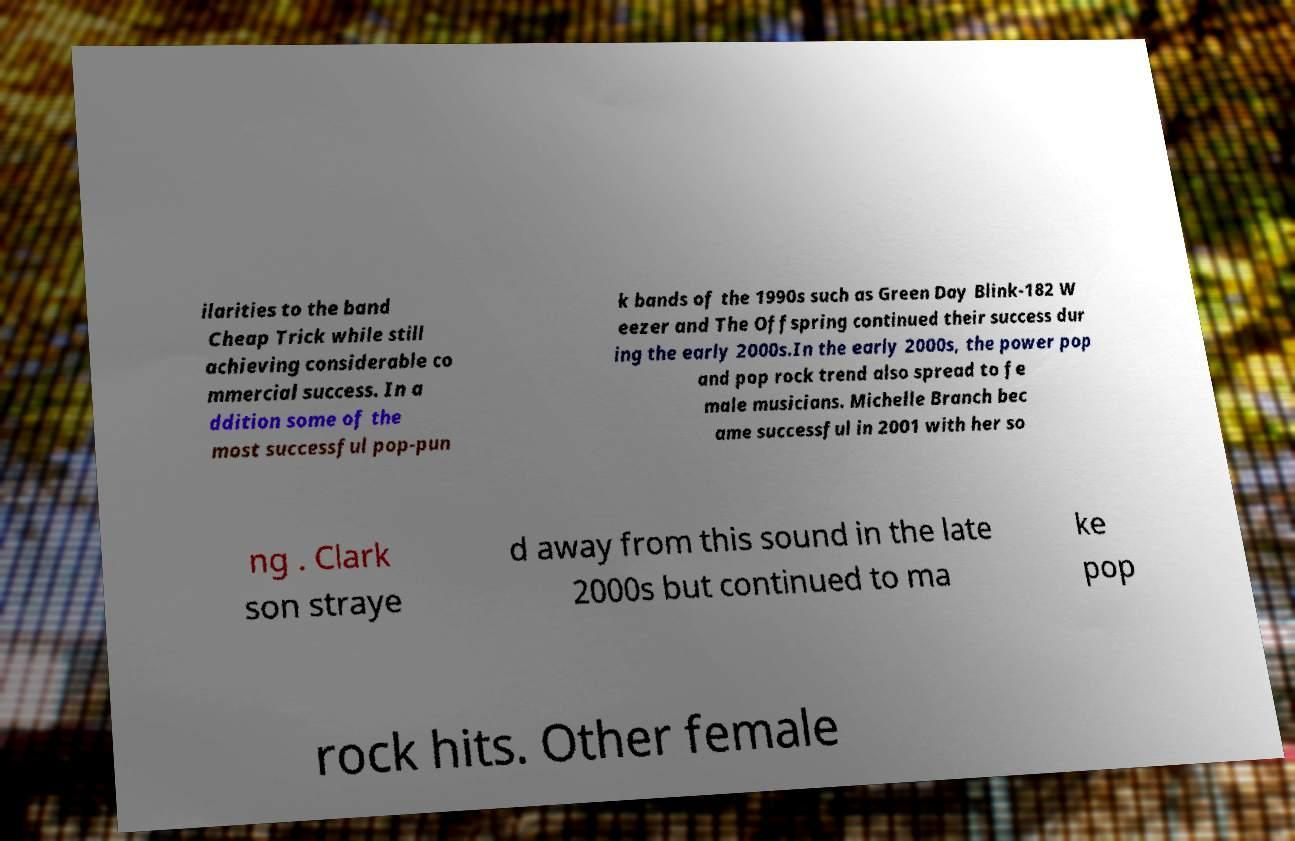Could you extract and type out the text from this image? ilarities to the band Cheap Trick while still achieving considerable co mmercial success. In a ddition some of the most successful pop-pun k bands of the 1990s such as Green Day Blink-182 W eezer and The Offspring continued their success dur ing the early 2000s.In the early 2000s, the power pop and pop rock trend also spread to fe male musicians. Michelle Branch bec ame successful in 2001 with her so ng . Clark son straye d away from this sound in the late 2000s but continued to ma ke pop rock hits. Other female 